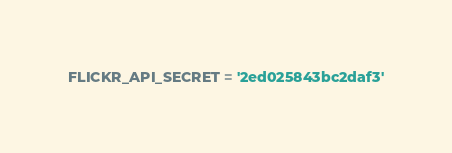<code> <loc_0><loc_0><loc_500><loc_500><_Python_>FLICKR_API_SECRET = '2ed025843bc2daf3'</code> 